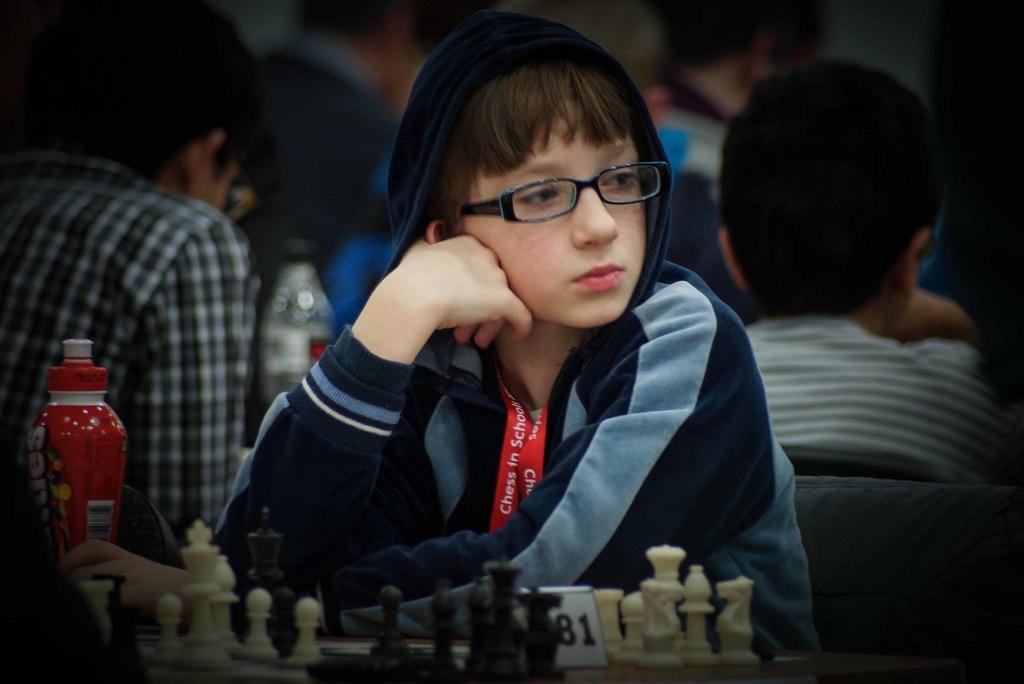How would you summarize this image in a sentence or two? In this image i can see a person sitting there are few chess coins, a bottles on a table at the back ground i can see few persons sitting and a bottle. 